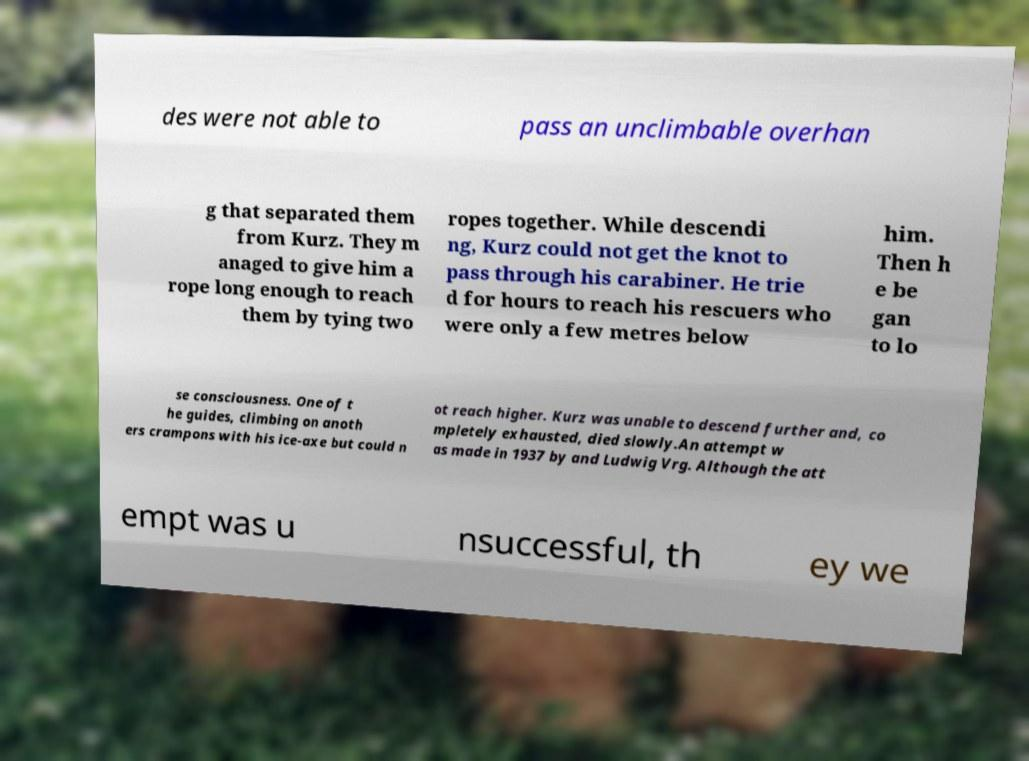There's text embedded in this image that I need extracted. Can you transcribe it verbatim? des were not able to pass an unclimbable overhan g that separated them from Kurz. They m anaged to give him a rope long enough to reach them by tying two ropes together. While descendi ng, Kurz could not get the knot to pass through his carabiner. He trie d for hours to reach his rescuers who were only a few metres below him. Then h e be gan to lo se consciousness. One of t he guides, climbing on anoth ers crampons with his ice-axe but could n ot reach higher. Kurz was unable to descend further and, co mpletely exhausted, died slowly.An attempt w as made in 1937 by and Ludwig Vrg. Although the att empt was u nsuccessful, th ey we 